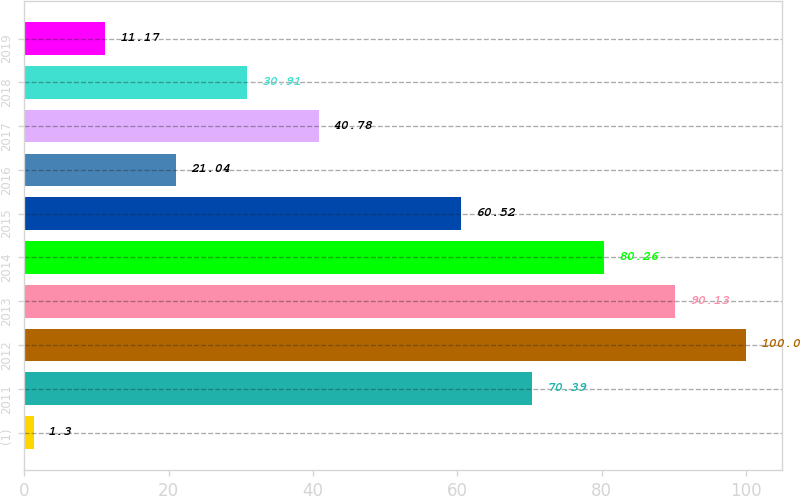Convert chart. <chart><loc_0><loc_0><loc_500><loc_500><bar_chart><fcel>(1)<fcel>2011<fcel>2012<fcel>2013<fcel>2014<fcel>2015<fcel>2016<fcel>2017<fcel>2018<fcel>2019<nl><fcel>1.3<fcel>70.39<fcel>100<fcel>90.13<fcel>80.26<fcel>60.52<fcel>21.04<fcel>40.78<fcel>30.91<fcel>11.17<nl></chart> 